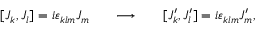Convert formula to latex. <formula><loc_0><loc_0><loc_500><loc_500>[ J _ { k } , J _ { l } ] = i \varepsilon _ { k l m } J _ { m } \quad \ \longrightarrow \quad \ [ J _ { k } ^ { \prime } , J _ { l } ^ { \prime } ] = i \varepsilon _ { k l m } J _ { m } ^ { \prime } ,</formula> 